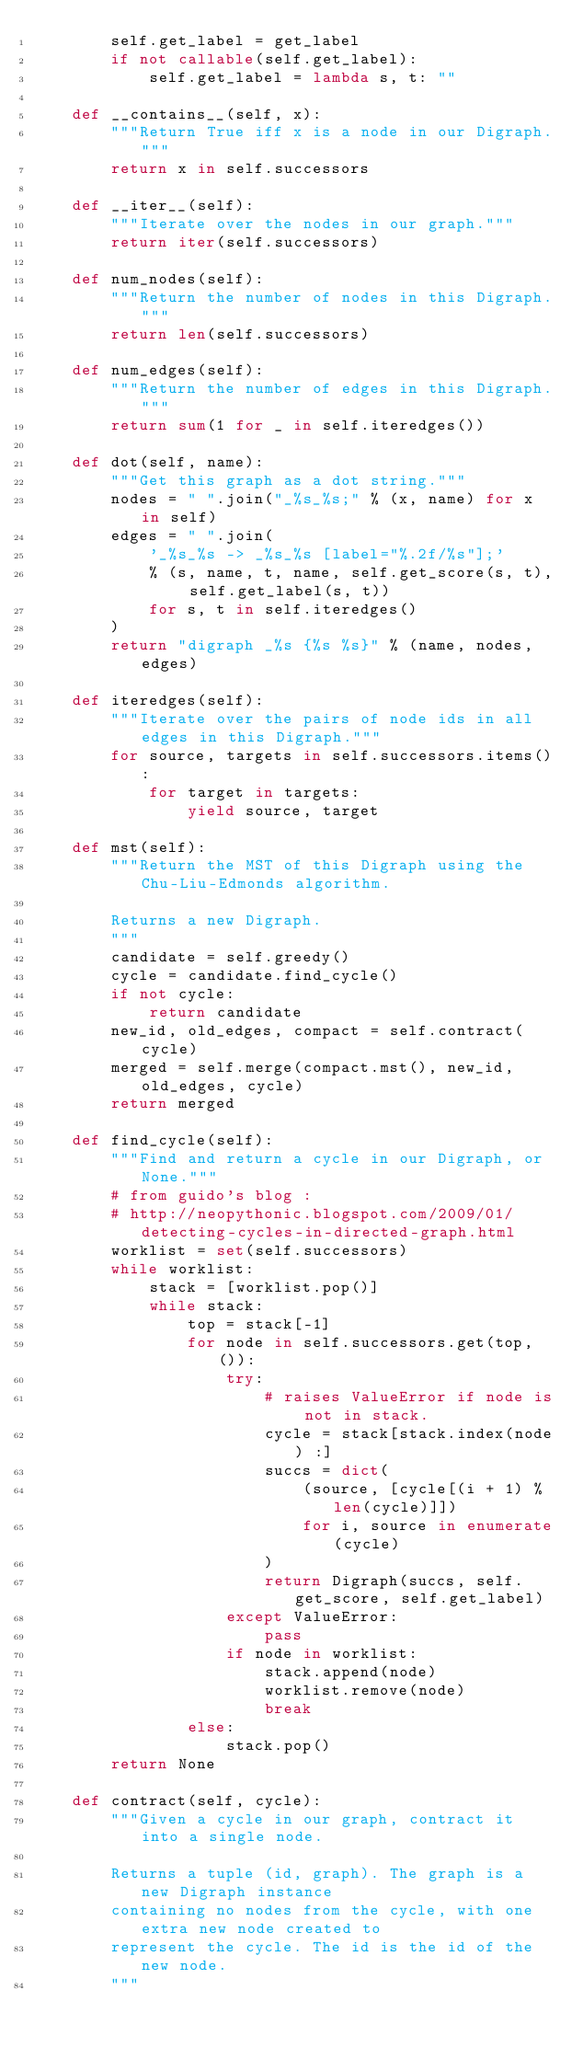<code> <loc_0><loc_0><loc_500><loc_500><_Python_>        self.get_label = get_label
        if not callable(self.get_label):
            self.get_label = lambda s, t: ""

    def __contains__(self, x):
        """Return True iff x is a node in our Digraph."""
        return x in self.successors

    def __iter__(self):
        """Iterate over the nodes in our graph."""
        return iter(self.successors)

    def num_nodes(self):
        """Return the number of nodes in this Digraph."""
        return len(self.successors)

    def num_edges(self):
        """Return the number of edges in this Digraph."""
        return sum(1 for _ in self.iteredges())

    def dot(self, name):
        """Get this graph as a dot string."""
        nodes = " ".join("_%s_%s;" % (x, name) for x in self)
        edges = " ".join(
            '_%s_%s -> _%s_%s [label="%.2f/%s"];'
            % (s, name, t, name, self.get_score(s, t), self.get_label(s, t))
            for s, t in self.iteredges()
        )
        return "digraph _%s {%s %s}" % (name, nodes, edges)

    def iteredges(self):
        """Iterate over the pairs of node ids in all edges in this Digraph."""
        for source, targets in self.successors.items():
            for target in targets:
                yield source, target

    def mst(self):
        """Return the MST of this Digraph using the Chu-Liu-Edmonds algorithm.

        Returns a new Digraph.
        """
        candidate = self.greedy()
        cycle = candidate.find_cycle()
        if not cycle:
            return candidate
        new_id, old_edges, compact = self.contract(cycle)
        merged = self.merge(compact.mst(), new_id, old_edges, cycle)
        return merged

    def find_cycle(self):
        """Find and return a cycle in our Digraph, or None."""
        # from guido's blog :
        # http://neopythonic.blogspot.com/2009/01/detecting-cycles-in-directed-graph.html
        worklist = set(self.successors)
        while worklist:
            stack = [worklist.pop()]
            while stack:
                top = stack[-1]
                for node in self.successors.get(top, ()):
                    try:
                        # raises ValueError if node is not in stack.
                        cycle = stack[stack.index(node) :]
                        succs = dict(
                            (source, [cycle[(i + 1) % len(cycle)]])
                            for i, source in enumerate(cycle)
                        )
                        return Digraph(succs, self.get_score, self.get_label)
                    except ValueError:
                        pass
                    if node in worklist:
                        stack.append(node)
                        worklist.remove(node)
                        break
                else:
                    stack.pop()
        return None

    def contract(self, cycle):
        """Given a cycle in our graph, contract it into a single node.

        Returns a tuple (id, graph). The graph is a new Digraph instance
        containing no nodes from the cycle, with one extra new node created to
        represent the cycle. The id is the id of the new node.
        """</code> 